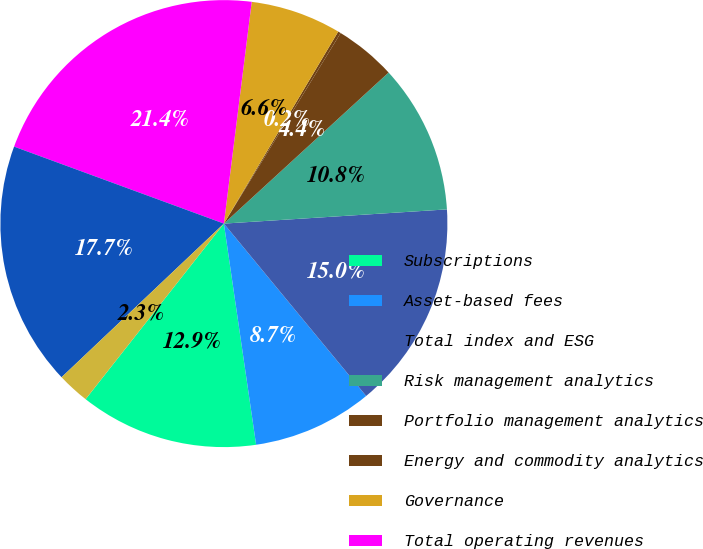Convert chart. <chart><loc_0><loc_0><loc_500><loc_500><pie_chart><fcel>Subscriptions<fcel>Asset-based fees<fcel>Total index and ESG<fcel>Risk management analytics<fcel>Portfolio management analytics<fcel>Energy and commodity analytics<fcel>Governance<fcel>Total operating revenues<fcel>Recurring subscriptions<fcel>Non-recurring revenue<nl><fcel>12.92%<fcel>8.68%<fcel>15.03%<fcel>10.8%<fcel>4.44%<fcel>0.2%<fcel>6.56%<fcel>21.39%<fcel>17.66%<fcel>2.32%<nl></chart> 